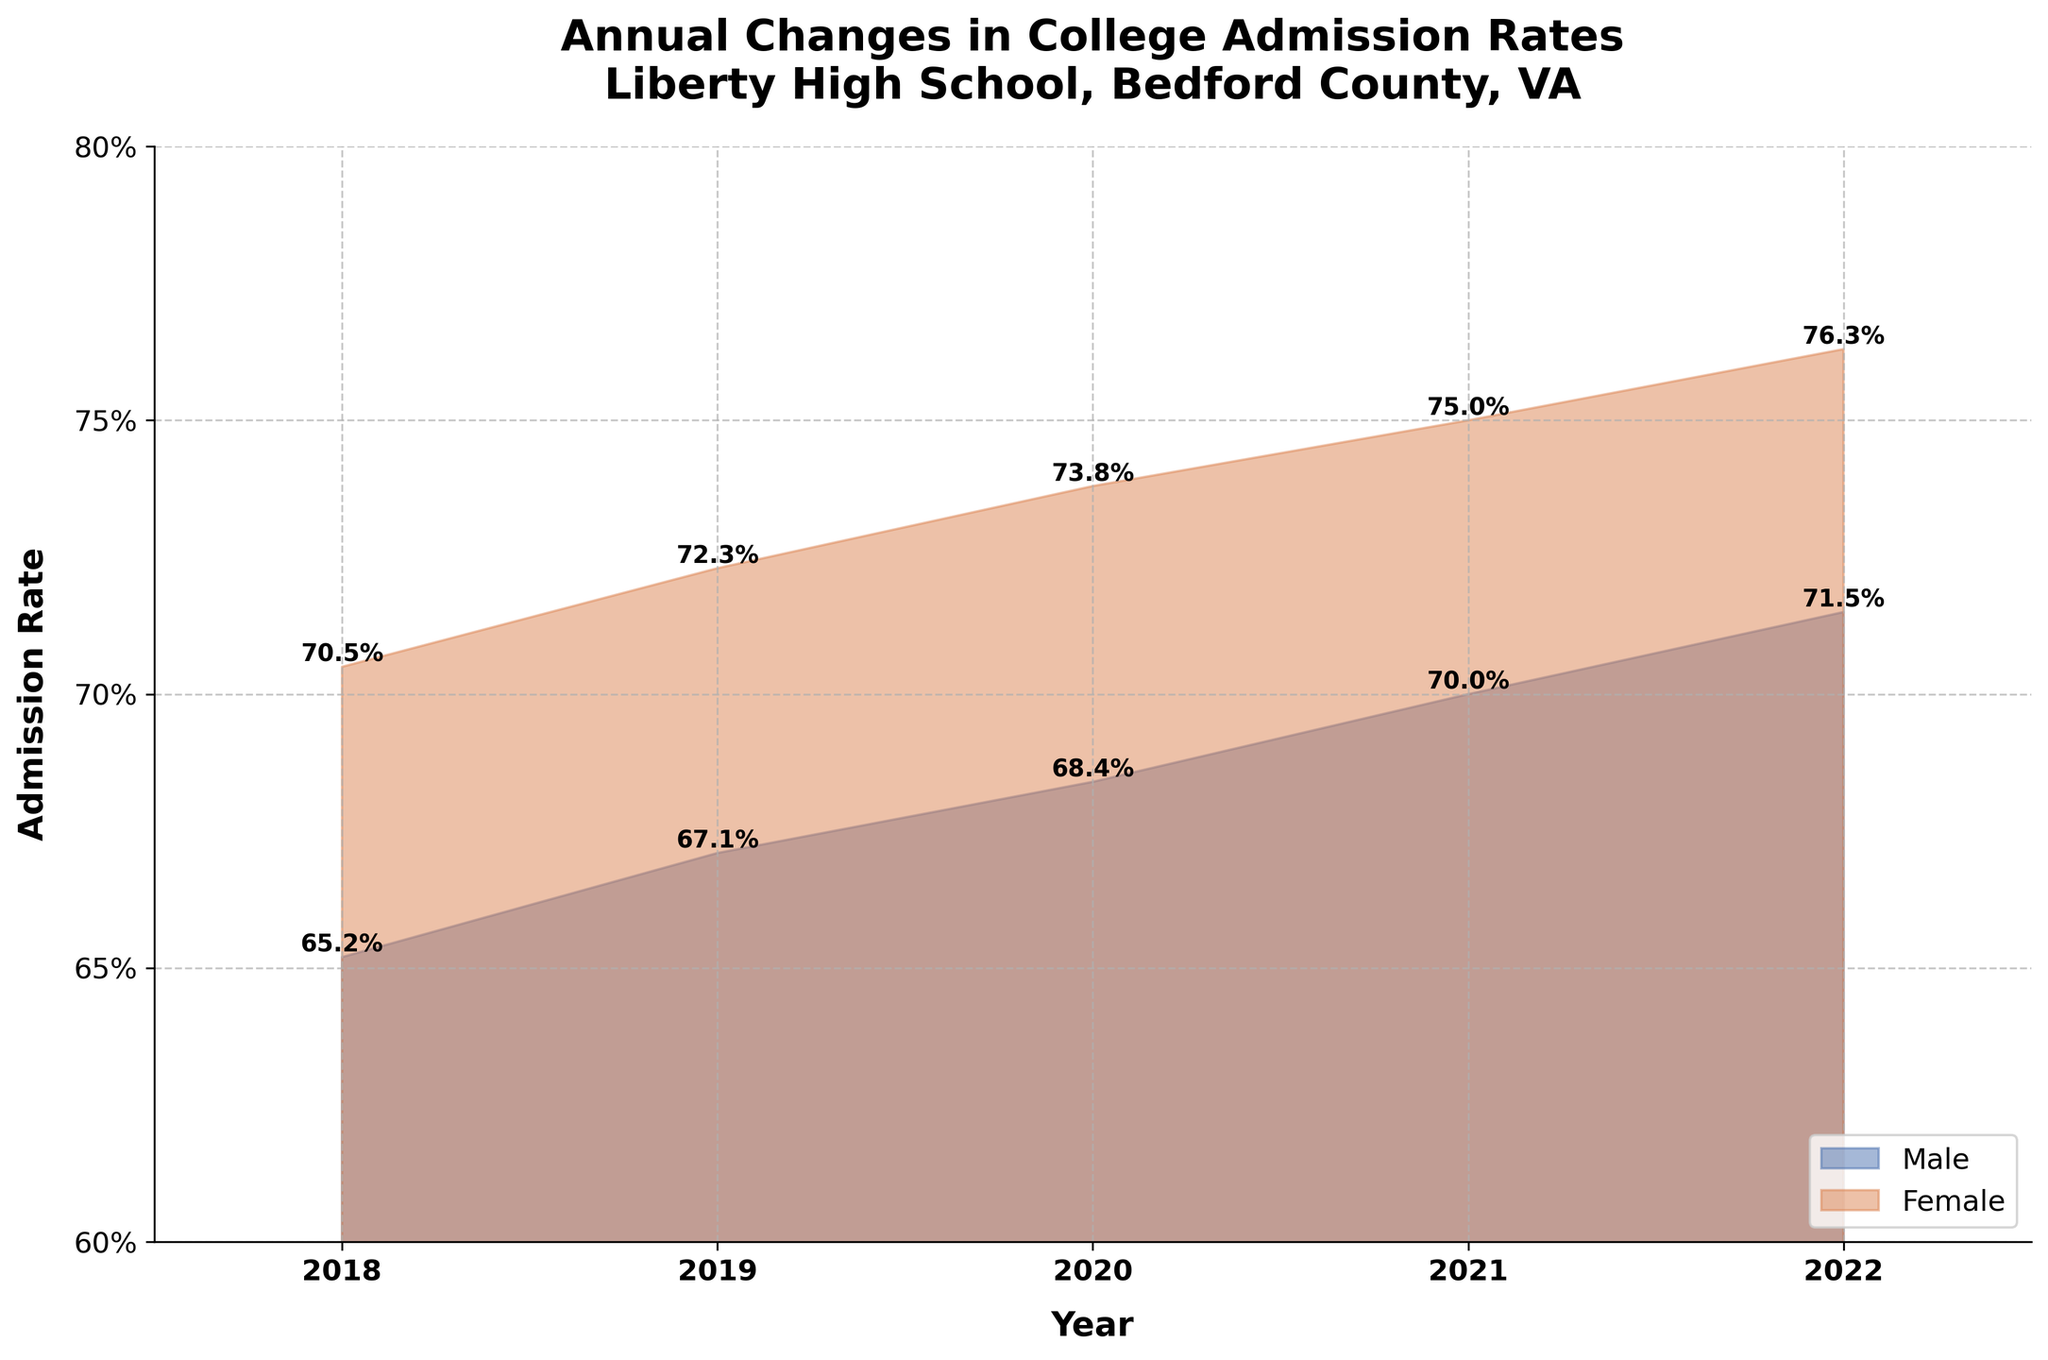What is the title of the figure? The title is located at the top of the figure and summarizes what the chart is about.
Answer: Annual Changes in College Admission Rates, Liberty High School, Bedford County, VA What are the years covered in the chart? The years are shown on the x-axis of the chart, which starts from the leftmost to the rightmost side.
Answer: 2018 to 2022 Which gender had a higher college admission rate in 2020? By examining the figure, we can compare the heights of the areas for males and females at the point representing the year 2020. The female area is higher.
Answer: Female What is the admission rate for males in 2019? The admission rate for males in 2019 can be found by looking at the corresponding point on the figure for males in the year 2019.
Answer: 67.1% How did the admission rate for females change from 2018 to 2022? We track the height of the female area from 2018 to 2022 and observe the increase. The rate went from 70.5% in 2018 to 76.3% in 2022.
Answer: It increased What is the difference in admission rates between males and females in 2022? To find the difference, we subtract the male admission rate from the female admission rate for the year 2022. 76.3% - 71.5% = 4.8%.
Answer: 4.8% Which year had the smallest gap between male and female admission rates? By comparing the gap between male and female admission rates for each year, we find that 2018 had the smallest gap. In 2018, the gap is 70.5% - 65.2% = 5.3%.
Answer: 2018 What trend do you observe in the admission rates for both genders over the years? Both the male and female admission rates show a general upward trend from 2018 to 2022 as the areas increase in height towards the right side of the figure.
Answer: Upward trend What was the highest admission rate achieved by males and in which year? By examining the highest point within the male area, we see that the highest admission rate was 71.5% in 2022.
Answer: 71.5% in 2022 Calculate the average admission rate for females over the years 2018-2022. To find the average, we sum up the female admission rates for all the years and divide by the number of years. (70.5 + 72.3 + 73.8 + 75.0 + 76.3) / 5 = 73.58%.
Answer: 73.58% 